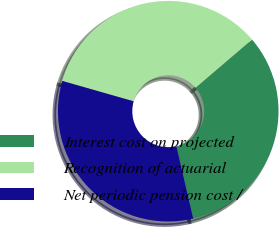<chart> <loc_0><loc_0><loc_500><loc_500><pie_chart><fcel>Interest cost on projected<fcel>Recognition of actuarial<fcel>Net periodic pension cost /<nl><fcel>32.61%<fcel>34.32%<fcel>33.07%<nl></chart> 